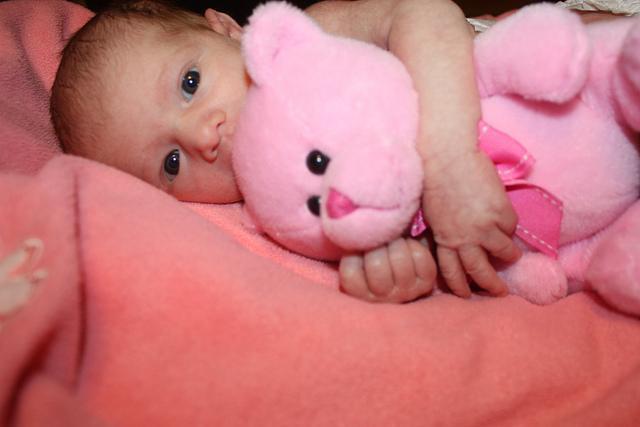Is the statement "The person is left of the teddy bear." accurate regarding the image?
Answer yes or no. No. 